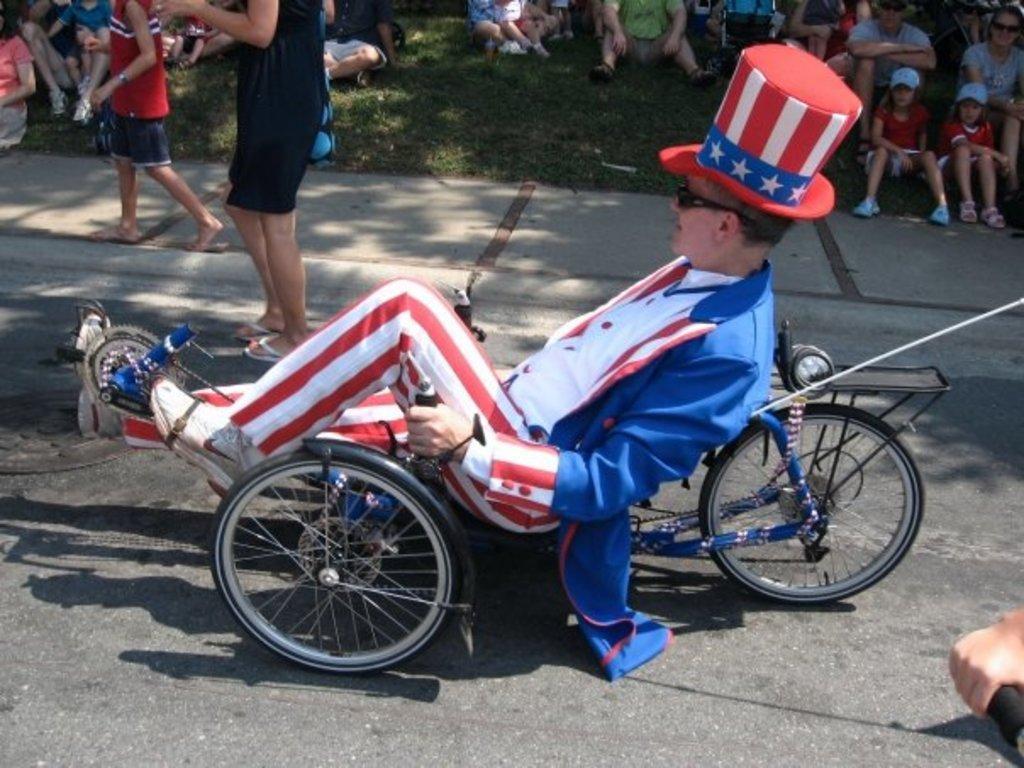Please provide a concise description of this image. In the picture, it is a road and a person is performing some action using the cycle , he is wearing red color hat, a blue color coat and red and white pant and white shoes , beside this person there are lot of people sitting on the grass , a woman and a kid are standing on the road beside him. 